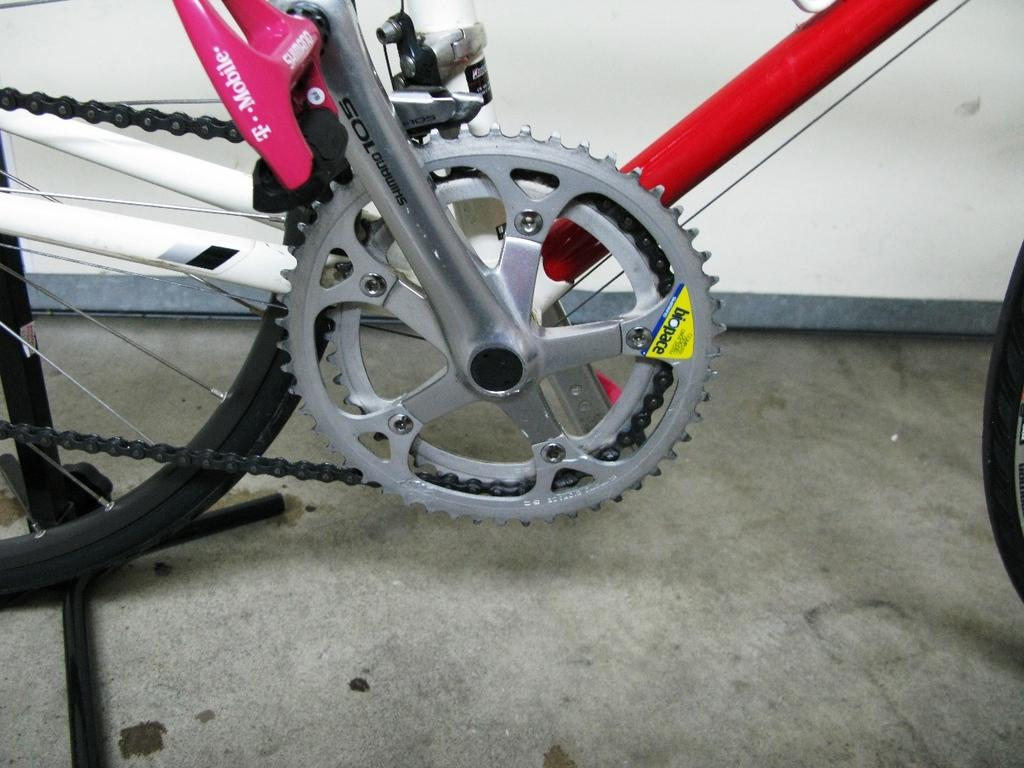What is the main object in the image? There is a bicycle in the image. What specific feature can be seen on the bicycle? The bicycle has a chain ring. What is another essential component of the bicycle? The bicycle has a wheel. Can you describe the wheel in more detail? The wheel has spokes. Are there any other parts of the bicycle visible in the image? There are other unspecified parts attached to the bicycle. What else can be seen in the image besides the bicycle? There is a wall in the image. What is the tax rate for the bicycle in the image? There is no information about tax rates in the image, as it only shows a bicycle with specific features and a wall in the background. --- 